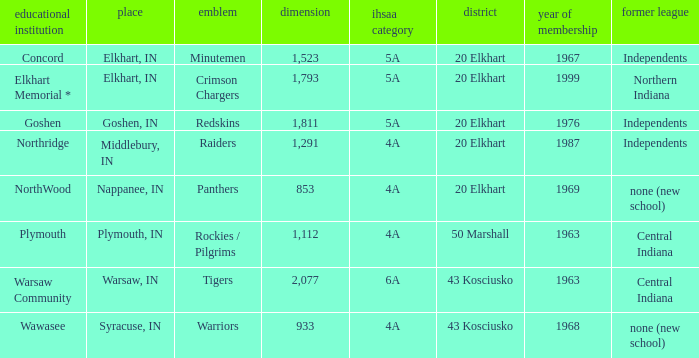What state entered prior to 1976, possessing an ihssa class of 5a, and a scale exceeding 1,112? 20 Elkhart. 